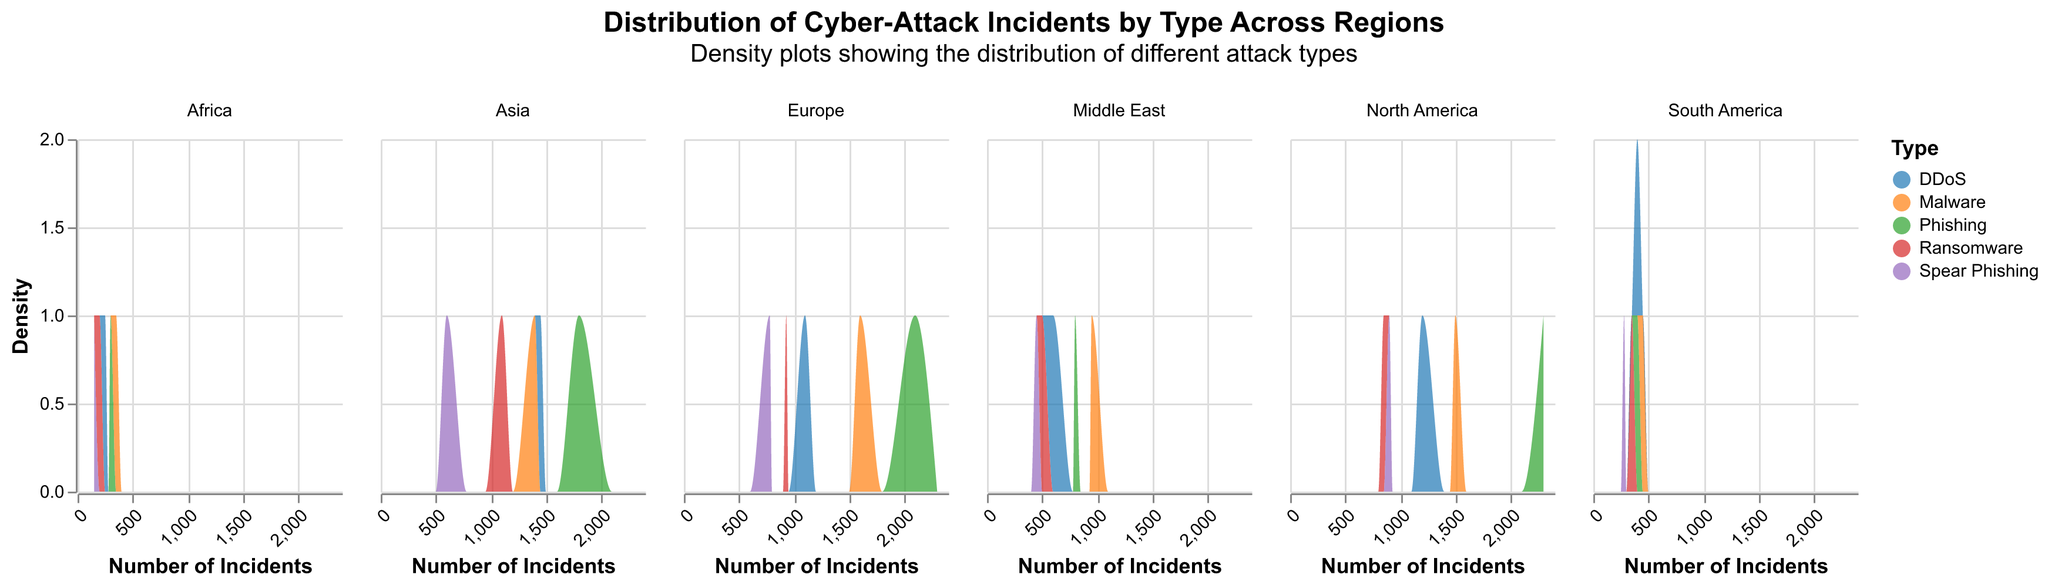Which region has the highest number of phishing incidents? Looking at the density plots for each region, North America has the highest density peak for phishing incidents, reaching up to 2300 incidents.
Answer: North America Which type of cyber-attack has the lowest incidence in Africa? By examining the density plot for Africa, Spear Phishing has the lowest number of incidents at 150.
Answer: Spear Phishing What is the general trend in the number of malware incidents from North America to Africa? Observing the density plots, the number of malware incidents generally decreases from North America (1500 incidents) to Africa (350 incidents).
Answer: Decreasing Which region has the widest range of incidents across all types of cyber-attacks? By looking at the densities, North America shows the widest range of incidents with values ranging from 850 (Ransomware) to 2300 (Phishing).
Answer: North America In which region is Ransomware slightly more frequent compared to Europe? Comparing the density plots, Asia has a slightly higher density for ransomware incidents (1100) compared to Europe (930).
Answer: Asia How does the distribution of DDoS incidents in Asia compare to North America? North America has a maximum DDoS incidents of 1200, while Asia has a slightly higher maximum of 1450.
Answer: Higher in Asia What is the trend of Spear Phishing incidents when moving from Europe to the Middle East? The density plot shows a decreasing trend from Europe (780) to the Middle East (450).
Answer: Decreasing Which region has the least diversified types of cyber-attacks? Africa has the least diversified types of cyber-attacks, with the lowest maximum incidents across all categories.
Answer: Africa 